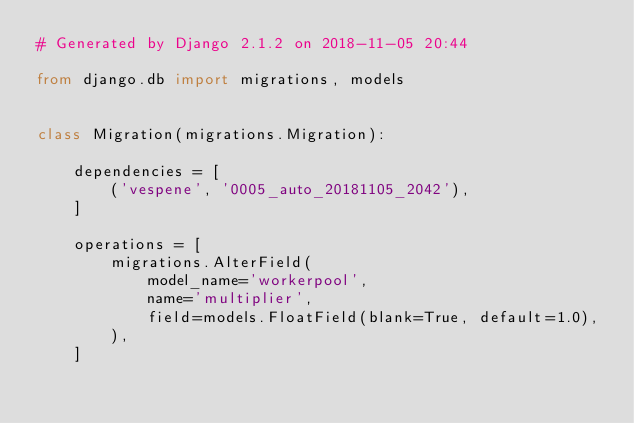<code> <loc_0><loc_0><loc_500><loc_500><_Python_># Generated by Django 2.1.2 on 2018-11-05 20:44

from django.db import migrations, models


class Migration(migrations.Migration):

    dependencies = [
        ('vespene', '0005_auto_20181105_2042'),
    ]

    operations = [
        migrations.AlterField(
            model_name='workerpool',
            name='multiplier',
            field=models.FloatField(blank=True, default=1.0),
        ),
    ]
</code> 